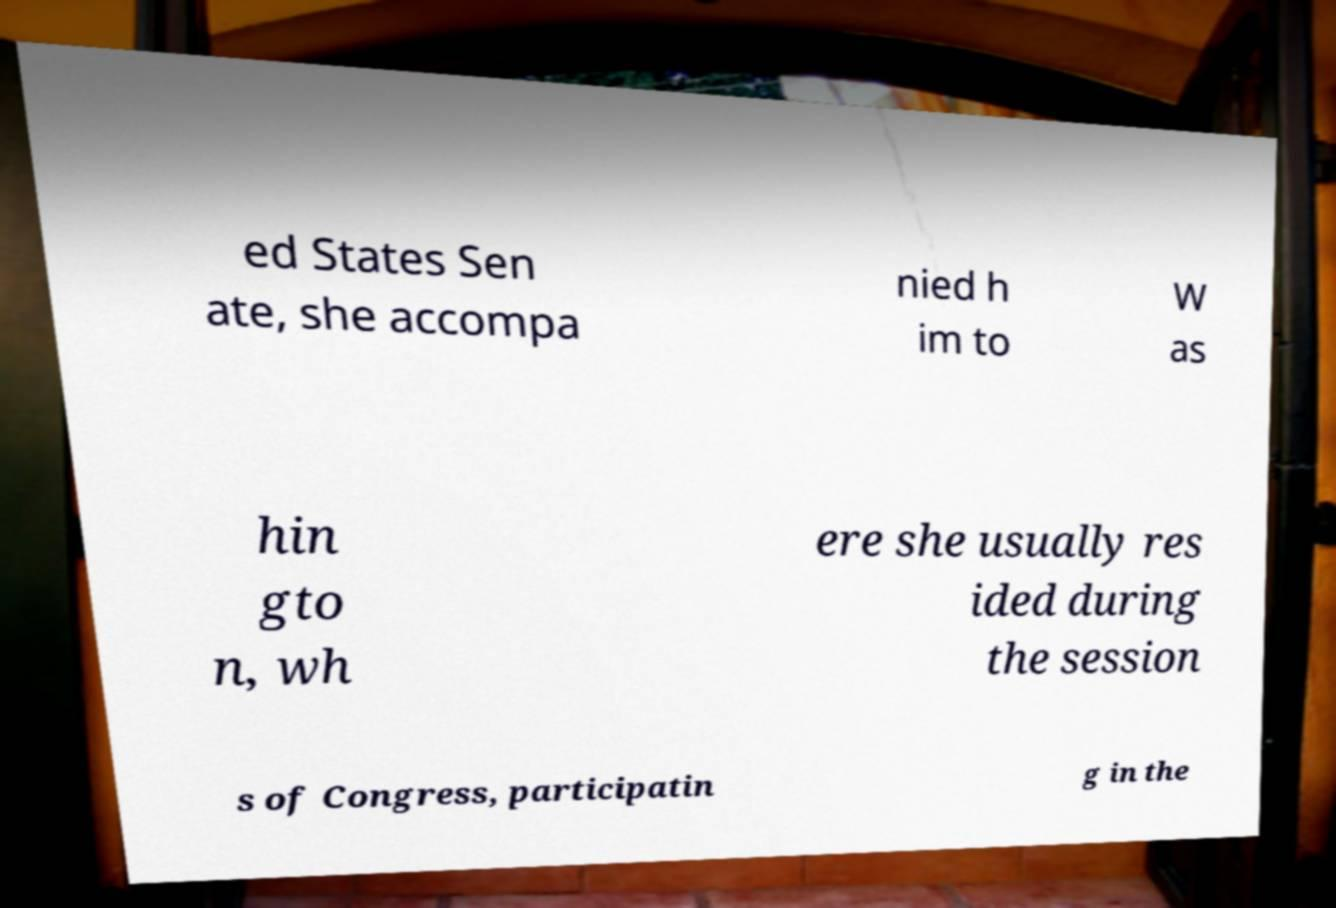Please identify and transcribe the text found in this image. ed States Sen ate, she accompa nied h im to W as hin gto n, wh ere she usually res ided during the session s of Congress, participatin g in the 